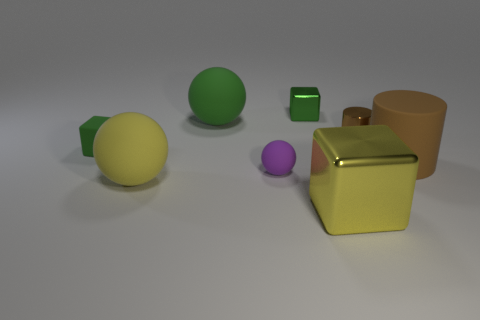Add 2 yellow cubes. How many objects exist? 10 Subtract all cubes. How many objects are left? 5 Subtract 0 red cubes. How many objects are left? 8 Subtract all tiny green shiny cylinders. Subtract all metal things. How many objects are left? 5 Add 5 big yellow cubes. How many big yellow cubes are left? 6 Add 5 small cyan blocks. How many small cyan blocks exist? 5 